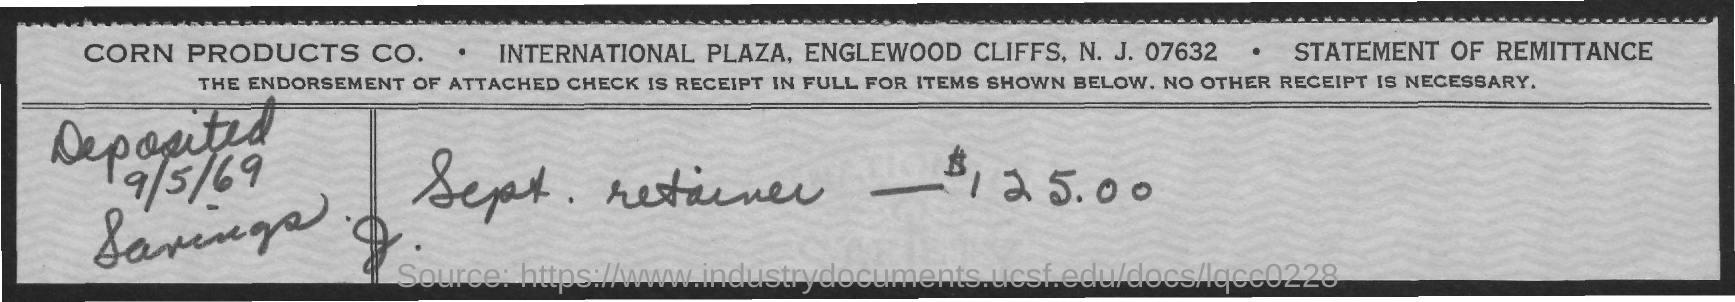What is the date on the document?
Make the answer very short. 9/5/69. What is the amount?
Offer a terse response. $ 125.00. 